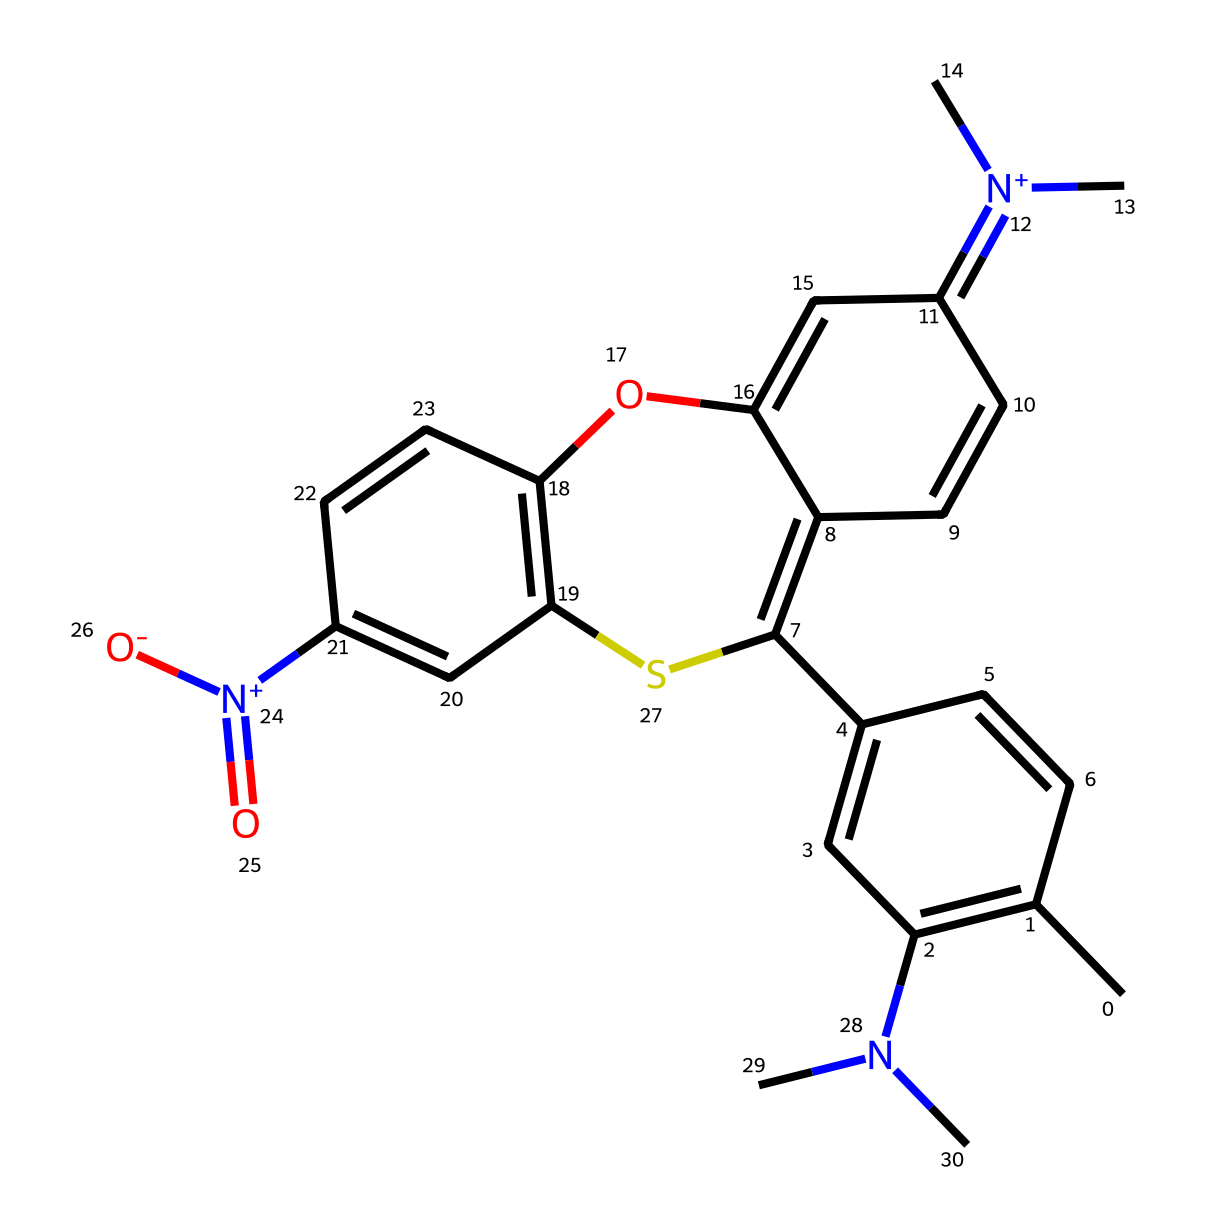What is the total number of nitrogen atoms in this chemical? By analyzing the SMILES representation, I can identify the presence of nitrogen atoms (N) in the structure. Counting the instances, there are a total of 3 nitrogen atoms present.
Answer: 3 How many aromatic rings are present in this dye? The structure contains several interconnected aromatic systems, specifically at least two distinct aromatic rings that can be identified from the cyclic carbon chains. Thus, there are two aromatic rings present.
Answer: 2 What is the charge on the nitrogen within this compound? Analyzing the SMILES, one nitrogen atom is denoted with a positive charge ([N+]), indicating that it carries a positive charge, while others are neutral. Thus, there is a positively charged nitrogen present.
Answer: positive Which functional group is indicated by the presence of the -O- atom in the structure? The -O- atom in the structure suggests the presence of an ether or an aromatic ether, which connects two aromatic regions. Thus, it indicates an ether function.
Answer: ether What type of molecular interaction does the photochromic property of this dye relate to? The photochromic properties arise from the ability of the dye to undergo reversible structural changes upon light exposure, relying on changes in π-electron systems and molecular orientation for these interactions.
Answer: π-electron system 